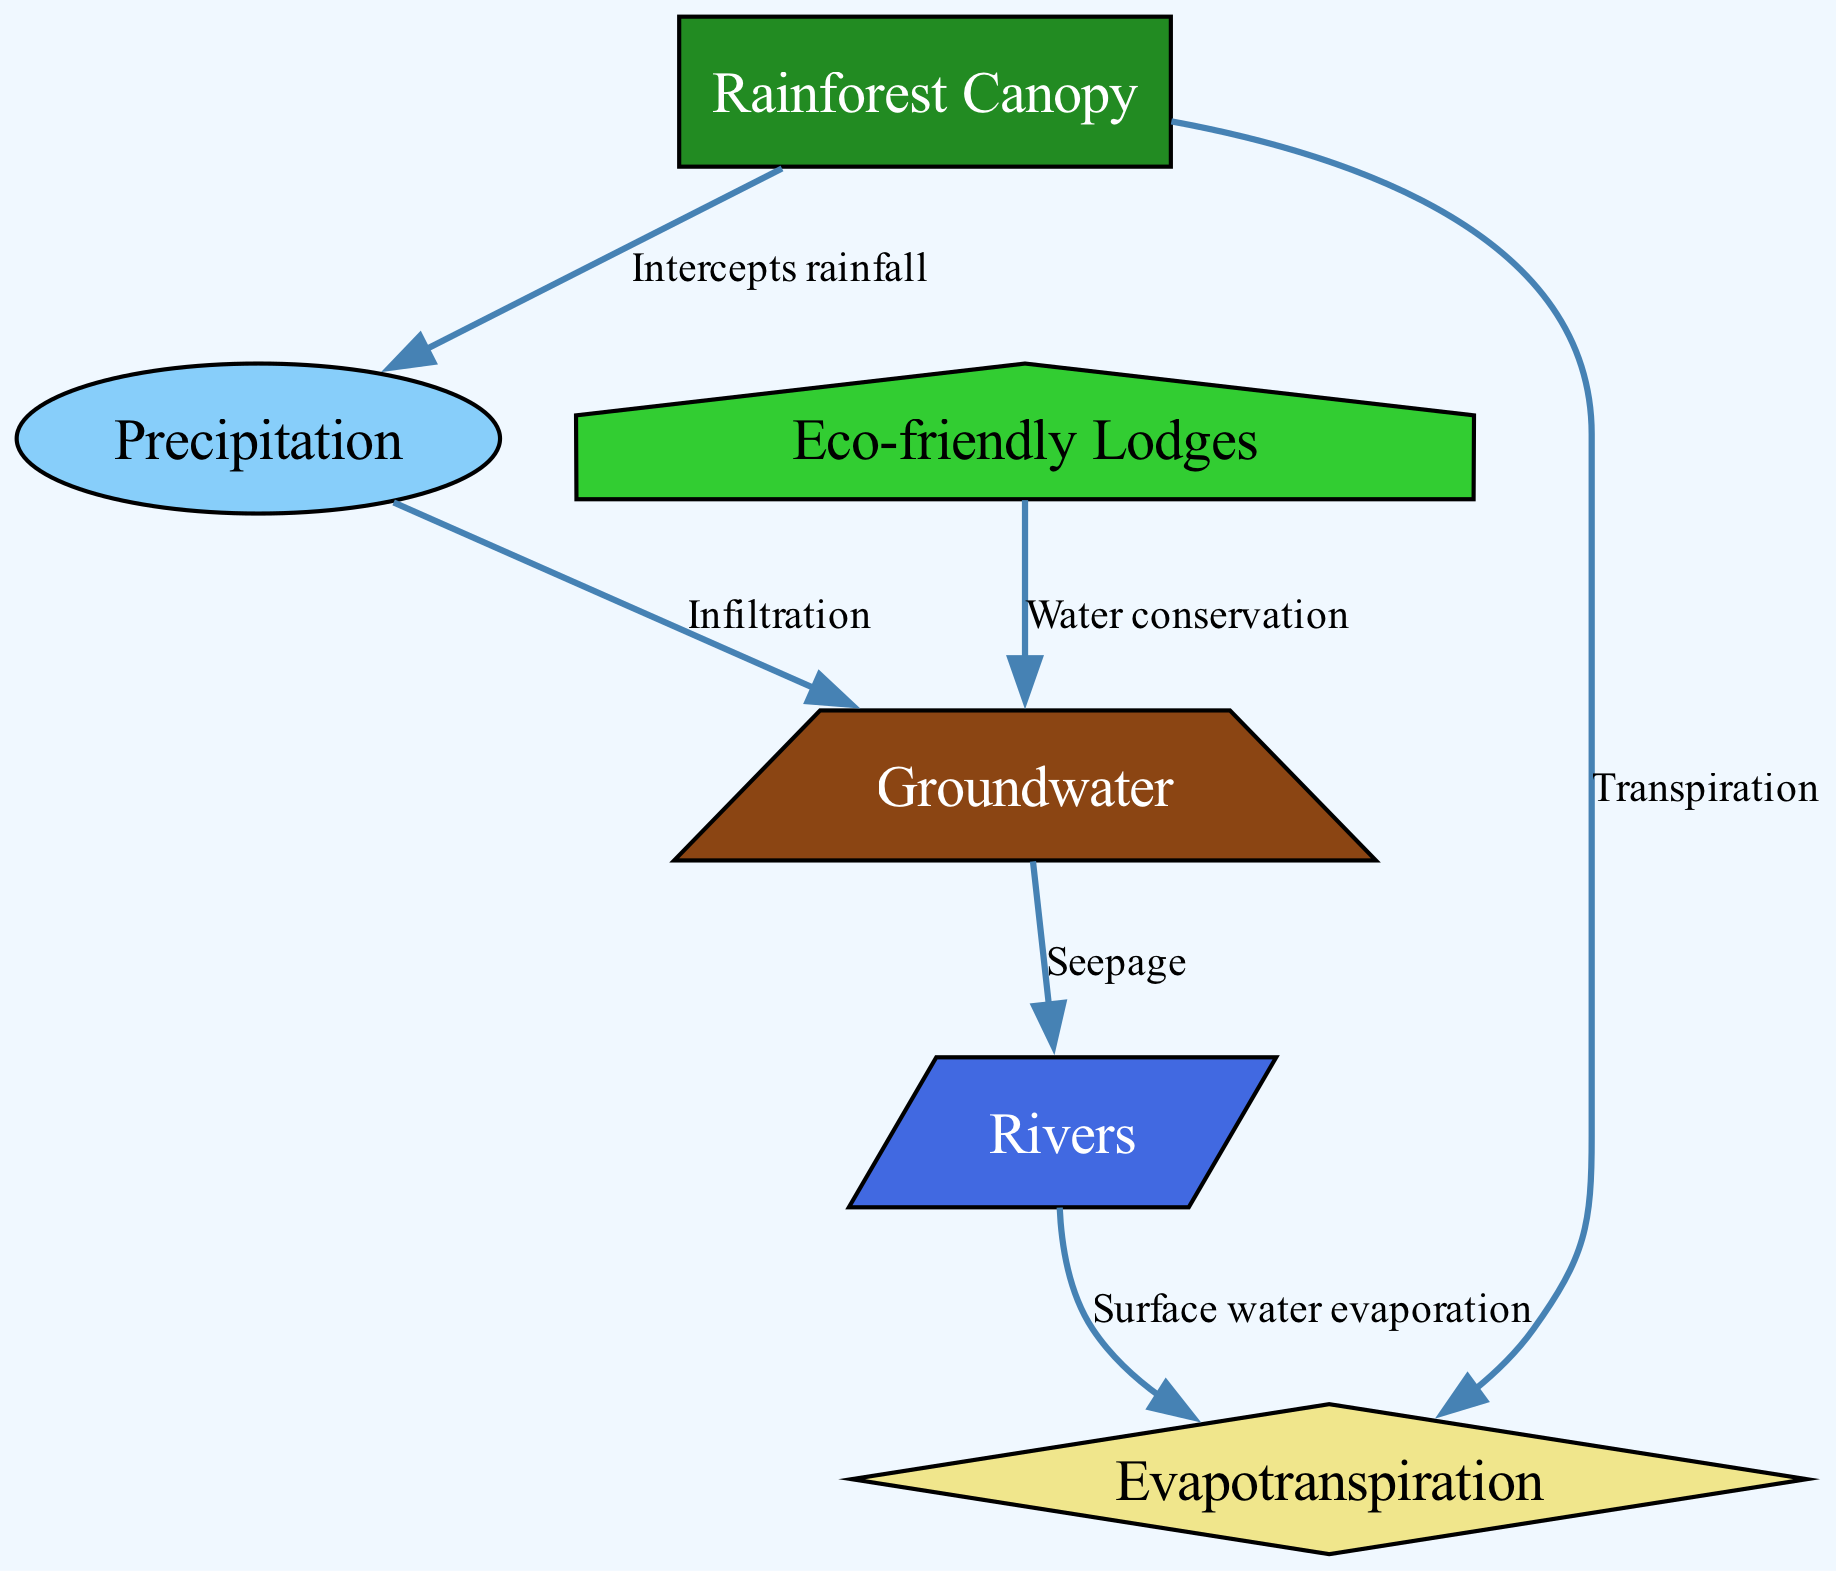What is the first process in the water cycle shown in the diagram? The diagram indicates that the first process in the water cycle is "Precipitation," which is the input to the cycle. It is depicted as the starting point leading to other processes.
Answer: Precipitation How many nodes represent water-related elements in the diagram? The diagram contains five nodes directly related to the water cycle: Rainforest Canopy, Precipitation, Evapotranspiration, Groundwater, and Rivers, highlighting the critical components of the cycle.
Answer: Five What action does the Rainforest Canopy perform regarding rainfall? The Rainforest Canopy intercepts rainfall, which is shown as a link between the Rainforest Canopy and the Precipitation node in the diagram.
Answer: Intercepts rainfall What is the final destination of water that seeps from groundwater? The diagram shows that the final destination of water that seeps from Groundwater is the Rivers. This relationship is explicitly illustrated as an arrow from Groundwater to Rivers.
Answer: Rivers How do eco-friendly lodges contribute to the groundwater in the diagram? Eco-friendly lodges promote Water Conservation, which is illustrated in the diagram as a direct connection from Eco-friendly Lodges to Groundwater, signifying their impact on preserving water resources.
Answer: Water conservation What is the relationship between Evapotranspiration and Rainforest Canopy? The diagram depicts a direct relationship where Evapotranspiration is linked to Rainforest Canopy through the process of Transpiration, indicating that water is released from the plants in the canopy.
Answer: Transpiration Which process in the diagram leads to surface water evaporation? The diagram clearly illustrates that the process leading to Surface Water Evaporation is from Rivers to Evapotranspiration. This trail indicates where water changes state from liquid to gas.
Answer: Surface water evaporation What type of lodging is emphasized for sustainable tourism practices in the diagram? The diagram emphasizes "Eco-friendly Lodges" as a type of lodging that supports sustainable tourism practices, which is represented as a specific node in the water cycle context.
Answer: Eco-friendly Lodges What process follows after precipitation in the water cycle? The action that follows Precipitation in the cycle is Infiltration, where water seeps into the ground, leading to the Groundwater node. This is depicted in the flow of the diagram.
Answer: Infiltration 